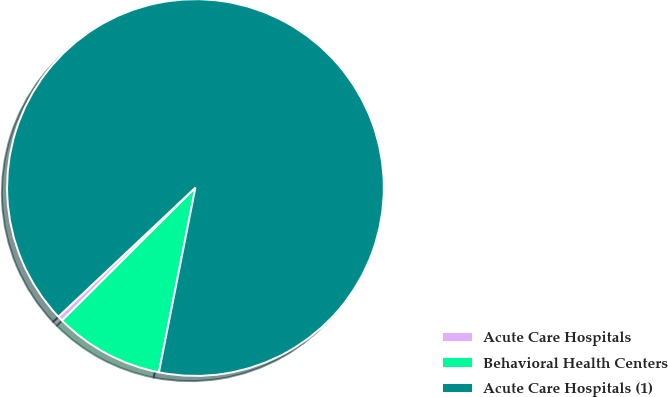Convert chart. <chart><loc_0><loc_0><loc_500><loc_500><pie_chart><fcel>Acute Care Hospitals<fcel>Behavioral Health Centers<fcel>Acute Care Hospitals (1)<nl><fcel>0.45%<fcel>9.42%<fcel>90.14%<nl></chart> 